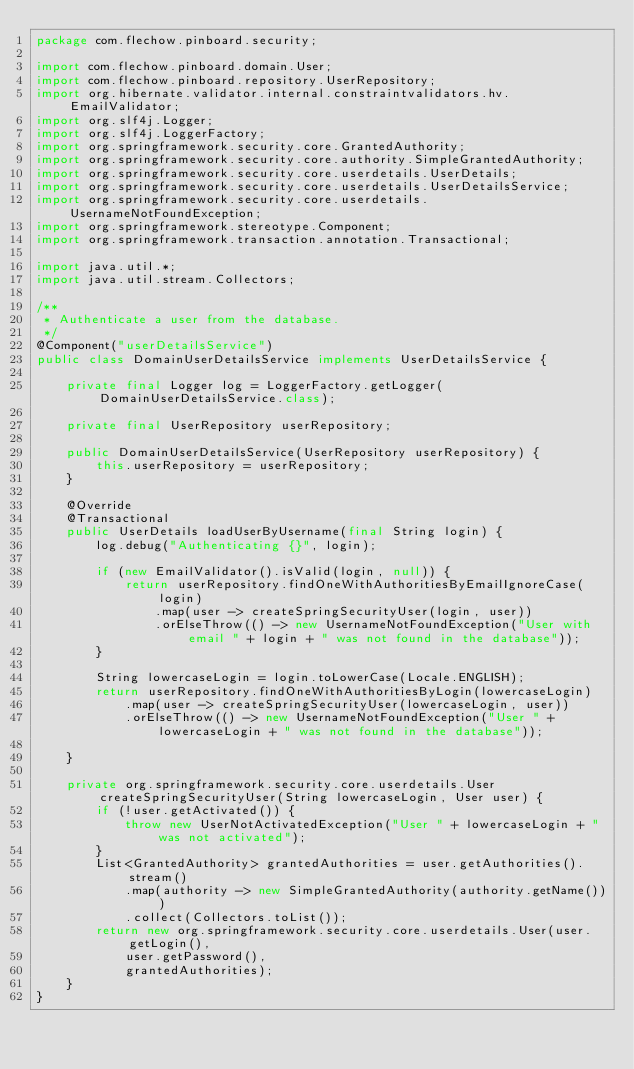<code> <loc_0><loc_0><loc_500><loc_500><_Java_>package com.flechow.pinboard.security;

import com.flechow.pinboard.domain.User;
import com.flechow.pinboard.repository.UserRepository;
import org.hibernate.validator.internal.constraintvalidators.hv.EmailValidator;
import org.slf4j.Logger;
import org.slf4j.LoggerFactory;
import org.springframework.security.core.GrantedAuthority;
import org.springframework.security.core.authority.SimpleGrantedAuthority;
import org.springframework.security.core.userdetails.UserDetails;
import org.springframework.security.core.userdetails.UserDetailsService;
import org.springframework.security.core.userdetails.UsernameNotFoundException;
import org.springframework.stereotype.Component;
import org.springframework.transaction.annotation.Transactional;

import java.util.*;
import java.util.stream.Collectors;

/**
 * Authenticate a user from the database.
 */
@Component("userDetailsService")
public class DomainUserDetailsService implements UserDetailsService {

    private final Logger log = LoggerFactory.getLogger(DomainUserDetailsService.class);

    private final UserRepository userRepository;

    public DomainUserDetailsService(UserRepository userRepository) {
        this.userRepository = userRepository;
    }

    @Override
    @Transactional
    public UserDetails loadUserByUsername(final String login) {
        log.debug("Authenticating {}", login);

        if (new EmailValidator().isValid(login, null)) {
            return userRepository.findOneWithAuthoritiesByEmailIgnoreCase(login)
                .map(user -> createSpringSecurityUser(login, user))
                .orElseThrow(() -> new UsernameNotFoundException("User with email " + login + " was not found in the database"));
        }

        String lowercaseLogin = login.toLowerCase(Locale.ENGLISH);
        return userRepository.findOneWithAuthoritiesByLogin(lowercaseLogin)
            .map(user -> createSpringSecurityUser(lowercaseLogin, user))
            .orElseThrow(() -> new UsernameNotFoundException("User " + lowercaseLogin + " was not found in the database"));

    }

    private org.springframework.security.core.userdetails.User createSpringSecurityUser(String lowercaseLogin, User user) {
        if (!user.getActivated()) {
            throw new UserNotActivatedException("User " + lowercaseLogin + " was not activated");
        }
        List<GrantedAuthority> grantedAuthorities = user.getAuthorities().stream()
            .map(authority -> new SimpleGrantedAuthority(authority.getName()))
            .collect(Collectors.toList());
        return new org.springframework.security.core.userdetails.User(user.getLogin(),
            user.getPassword(),
            grantedAuthorities);
    }
}
</code> 